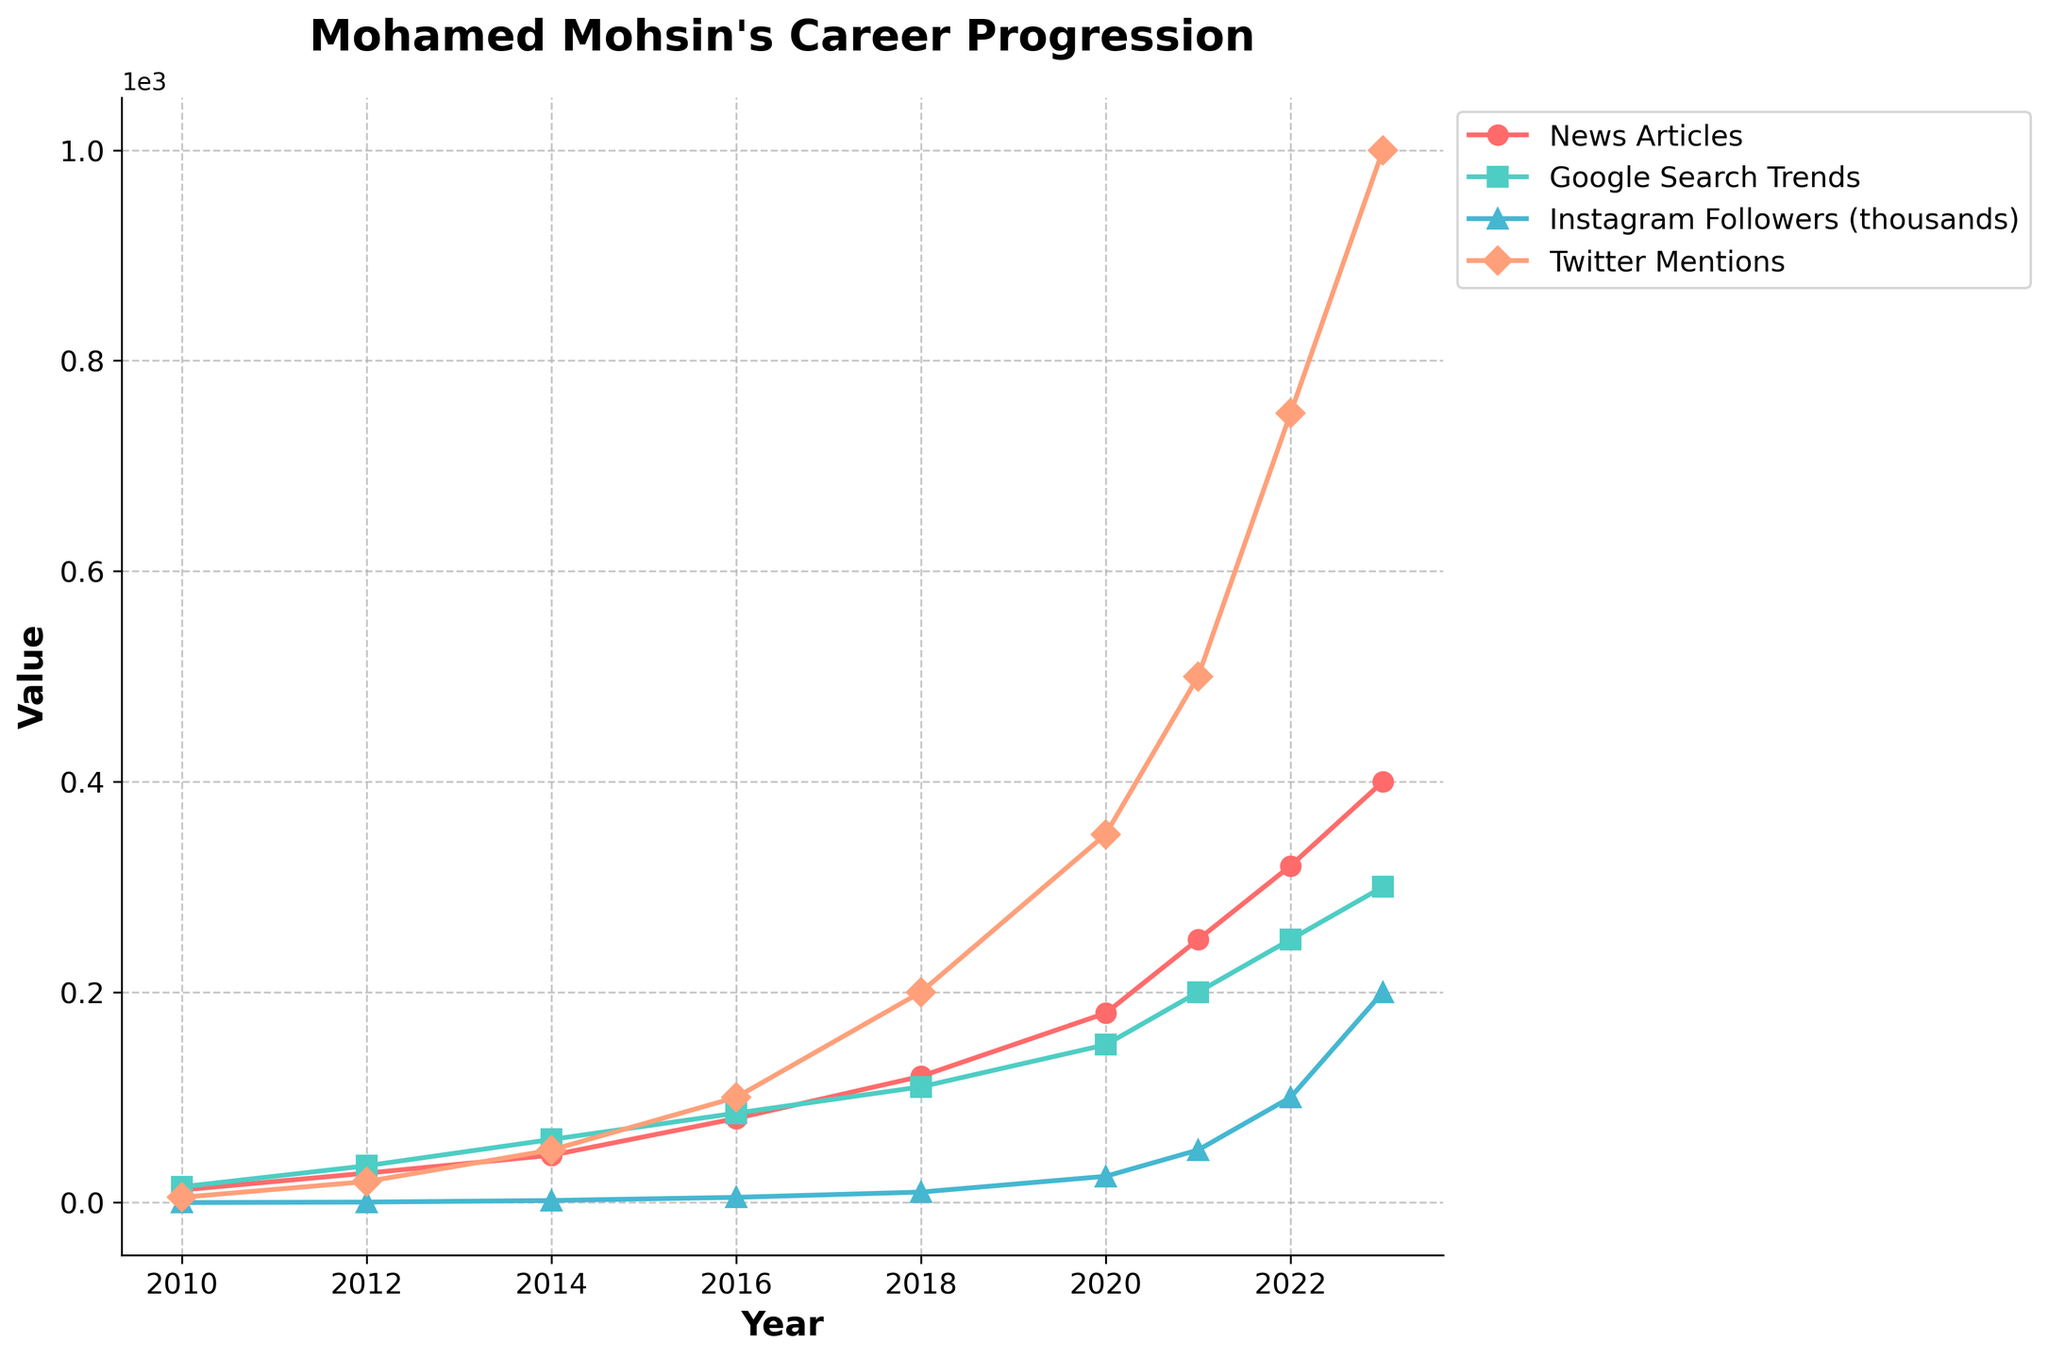what's the percentage increase in the number of news articles from 2018 to 2023? First, find the number of news articles for 2018 (120) and for 2023 (400). Then, use the formula for percentage increase: ((New Value - Old Value) / Old Value) * 100 = ((400 - 120) / 120) * 100
Answer: 233.33% During which year did the number of Google search trends for Mohamed Mohsin surpass 100? By observing the Google Search Trends line, it first surpasses 100 in the year 2018.
Answer: 2018 Which metric showed the highest overall increase from 2010 to 2023? Comparing the growth from 2010 to 2023 for all metrics, Instagram Followers increased from 0 to 200,000 (converted to 200,000 for comparison), which is the highest increase compared to News Articles, Google Search Trends, and Twitter Mentions.
Answer: Instagram Followers Is the growth trend of Twitter Mentions more consistent compared to Google Search Trends? Twitter Mentions show a more linear and consistent increase compared to Google Search Trends, which have a more varied slope.
Answer: Yes What is the sum of the values for news articles, Google search trends, Instagram followers (in thousands), and Twitter mentions in 2020? For 2020, the values are News Articles (180), Google Search Trends (150), Instagram Followers (25), and Twitter Mentions (350). Sum these values: 180 + 150 + 25 + 350 = 705
Answer: 705 Which year has the steepest increase in Instagram followers when compared to the previous year? By observing the steepness of the Instagram followers’ line, the steepest rise occurs from 2022 (100,000) to 2023 (200,000), an increase of 100,000.
Answer: 2023 What visual marker is used for representing Twitter mentions? The line representing Twitter Mentions uses a diamond marker (D).
Answer: Diamond marker Between 2010 and 2023, which year had the least number of public interests in Google's search trends? By referring to the Google Search Trends line, the lowest point from 2010 onwards is in 2010 with a value of 15.
Answer: 2010 Compare the total number of news articles and Twitter mentions in 2022. Are the articles greater than double the mentions? In 2022, there were 320 news articles and 750 Twitter mentions. To check if articles are greater than double mentions: 320 > 750 * 2. Clearly, 320 is not greater than 1500.
Answer: No 